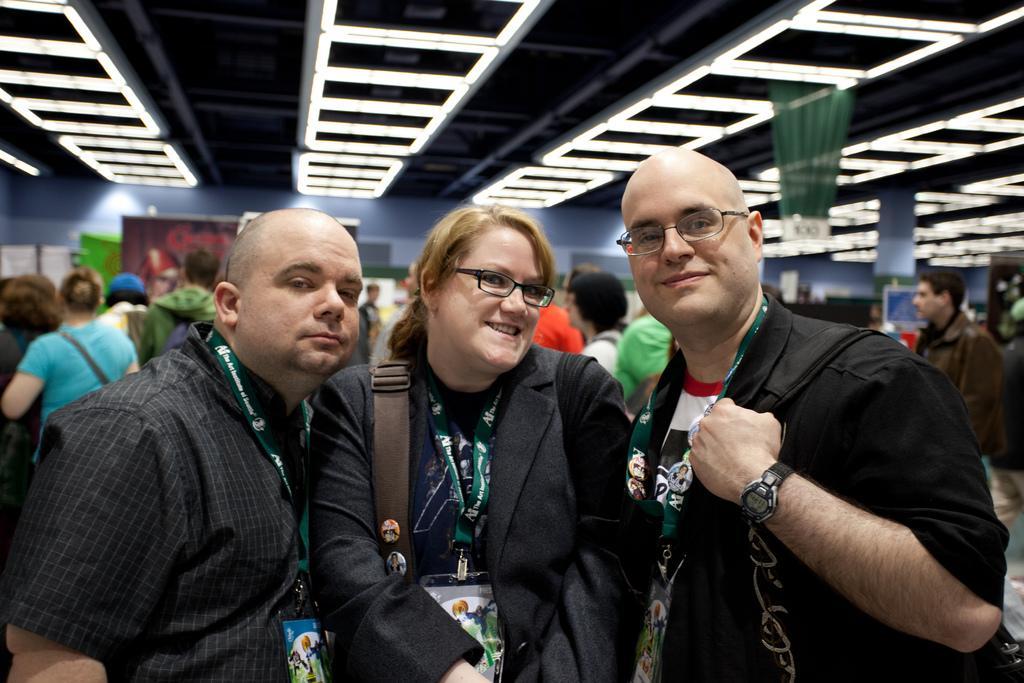Describe this image in one or two sentences. This picture shows few people are standing and we see couple of men and women. They wore ID cards and couple of them wore spectacles on their faces and they wore bags and we see smile on their faces and lights to the ceiling. 